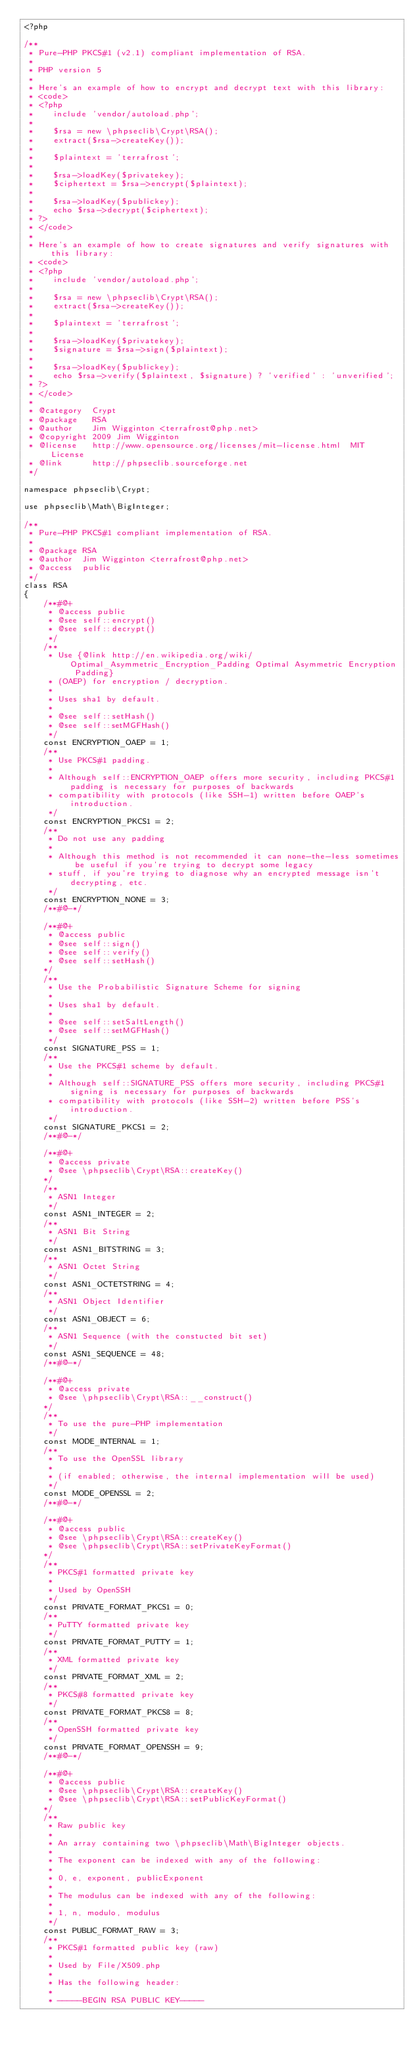Convert code to text. <code><loc_0><loc_0><loc_500><loc_500><_PHP_><?php

/**
 * Pure-PHP PKCS#1 (v2.1) compliant implementation of RSA.
 *
 * PHP version 5
 *
 * Here's an example of how to encrypt and decrypt text with this library:
 * <code>
 * <?php
 *    include 'vendor/autoload.php';
 *
 *    $rsa = new \phpseclib\Crypt\RSA();
 *    extract($rsa->createKey());
 *
 *    $plaintext = 'terrafrost';
 *
 *    $rsa->loadKey($privatekey);
 *    $ciphertext = $rsa->encrypt($plaintext);
 *
 *    $rsa->loadKey($publickey);
 *    echo $rsa->decrypt($ciphertext);
 * ?>
 * </code>
 *
 * Here's an example of how to create signatures and verify signatures with this library:
 * <code>
 * <?php
 *    include 'vendor/autoload.php';
 *
 *    $rsa = new \phpseclib\Crypt\RSA();
 *    extract($rsa->createKey());
 *
 *    $plaintext = 'terrafrost';
 *
 *    $rsa->loadKey($privatekey);
 *    $signature = $rsa->sign($plaintext);
 *
 *    $rsa->loadKey($publickey);
 *    echo $rsa->verify($plaintext, $signature) ? 'verified' : 'unverified';
 * ?>
 * </code>
 *
 * @category  Crypt
 * @package   RSA
 * @author    Jim Wigginton <terrafrost@php.net>
 * @copyright 2009 Jim Wigginton
 * @license   http://www.opensource.org/licenses/mit-license.html  MIT License
 * @link      http://phpseclib.sourceforge.net
 */

namespace phpseclib\Crypt;

use phpseclib\Math\BigInteger;

/**
 * Pure-PHP PKCS#1 compliant implementation of RSA.
 *
 * @package RSA
 * @author  Jim Wigginton <terrafrost@php.net>
 * @access  public
 */
class RSA
{
    /**#@+
     * @access public
     * @see self::encrypt()
     * @see self::decrypt()
     */
    /**
     * Use {@link http://en.wikipedia.org/wiki/Optimal_Asymmetric_Encryption_Padding Optimal Asymmetric Encryption Padding}
     * (OAEP) for encryption / decryption.
     *
     * Uses sha1 by default.
     *
     * @see self::setHash()
     * @see self::setMGFHash()
     */
    const ENCRYPTION_OAEP = 1;
    /**
     * Use PKCS#1 padding.
     *
     * Although self::ENCRYPTION_OAEP offers more security, including PKCS#1 padding is necessary for purposes of backwards
     * compatibility with protocols (like SSH-1) written before OAEP's introduction.
     */
    const ENCRYPTION_PKCS1 = 2;
    /**
     * Do not use any padding
     *
     * Although this method is not recommended it can none-the-less sometimes be useful if you're trying to decrypt some legacy
     * stuff, if you're trying to diagnose why an encrypted message isn't decrypting, etc.
     */
    const ENCRYPTION_NONE = 3;
    /**#@-*/

    /**#@+
     * @access public
     * @see self::sign()
     * @see self::verify()
     * @see self::setHash()
    */
    /**
     * Use the Probabilistic Signature Scheme for signing
     *
     * Uses sha1 by default.
     *
     * @see self::setSaltLength()
     * @see self::setMGFHash()
     */
    const SIGNATURE_PSS = 1;
    /**
     * Use the PKCS#1 scheme by default.
     *
     * Although self::SIGNATURE_PSS offers more security, including PKCS#1 signing is necessary for purposes of backwards
     * compatibility with protocols (like SSH-2) written before PSS's introduction.
     */
    const SIGNATURE_PKCS1 = 2;
    /**#@-*/

    /**#@+
     * @access private
     * @see \phpseclib\Crypt\RSA::createKey()
    */
    /**
     * ASN1 Integer
     */
    const ASN1_INTEGER = 2;
    /**
     * ASN1 Bit String
     */
    const ASN1_BITSTRING = 3;
    /**
     * ASN1 Octet String
     */
    const ASN1_OCTETSTRING = 4;
    /**
     * ASN1 Object Identifier
     */
    const ASN1_OBJECT = 6;
    /**
     * ASN1 Sequence (with the constucted bit set)
     */
    const ASN1_SEQUENCE = 48;
    /**#@-*/

    /**#@+
     * @access private
     * @see \phpseclib\Crypt\RSA::__construct()
    */
    /**
     * To use the pure-PHP implementation
     */
    const MODE_INTERNAL = 1;
    /**
     * To use the OpenSSL library
     *
     * (if enabled; otherwise, the internal implementation will be used)
     */
    const MODE_OPENSSL = 2;
    /**#@-*/

    /**#@+
     * @access public
     * @see \phpseclib\Crypt\RSA::createKey()
     * @see \phpseclib\Crypt\RSA::setPrivateKeyFormat()
    */
    /**
     * PKCS#1 formatted private key
     *
     * Used by OpenSSH
     */
    const PRIVATE_FORMAT_PKCS1 = 0;
    /**
     * PuTTY formatted private key
     */
    const PRIVATE_FORMAT_PUTTY = 1;
    /**
     * XML formatted private key
     */
    const PRIVATE_FORMAT_XML = 2;
    /**
     * PKCS#8 formatted private key
     */
    const PRIVATE_FORMAT_PKCS8 = 8;
    /**
     * OpenSSH formatted private key
     */
    const PRIVATE_FORMAT_OPENSSH = 9;
    /**#@-*/

    /**#@+
     * @access public
     * @see \phpseclib\Crypt\RSA::createKey()
     * @see \phpseclib\Crypt\RSA::setPublicKeyFormat()
    */
    /**
     * Raw public key
     *
     * An array containing two \phpseclib\Math\BigInteger objects.
     *
     * The exponent can be indexed with any of the following:
     *
     * 0, e, exponent, publicExponent
     *
     * The modulus can be indexed with any of the following:
     *
     * 1, n, modulo, modulus
     */
    const PUBLIC_FORMAT_RAW = 3;
    /**
     * PKCS#1 formatted public key (raw)
     *
     * Used by File/X509.php
     *
     * Has the following header:
     *
     * -----BEGIN RSA PUBLIC KEY-----</code> 